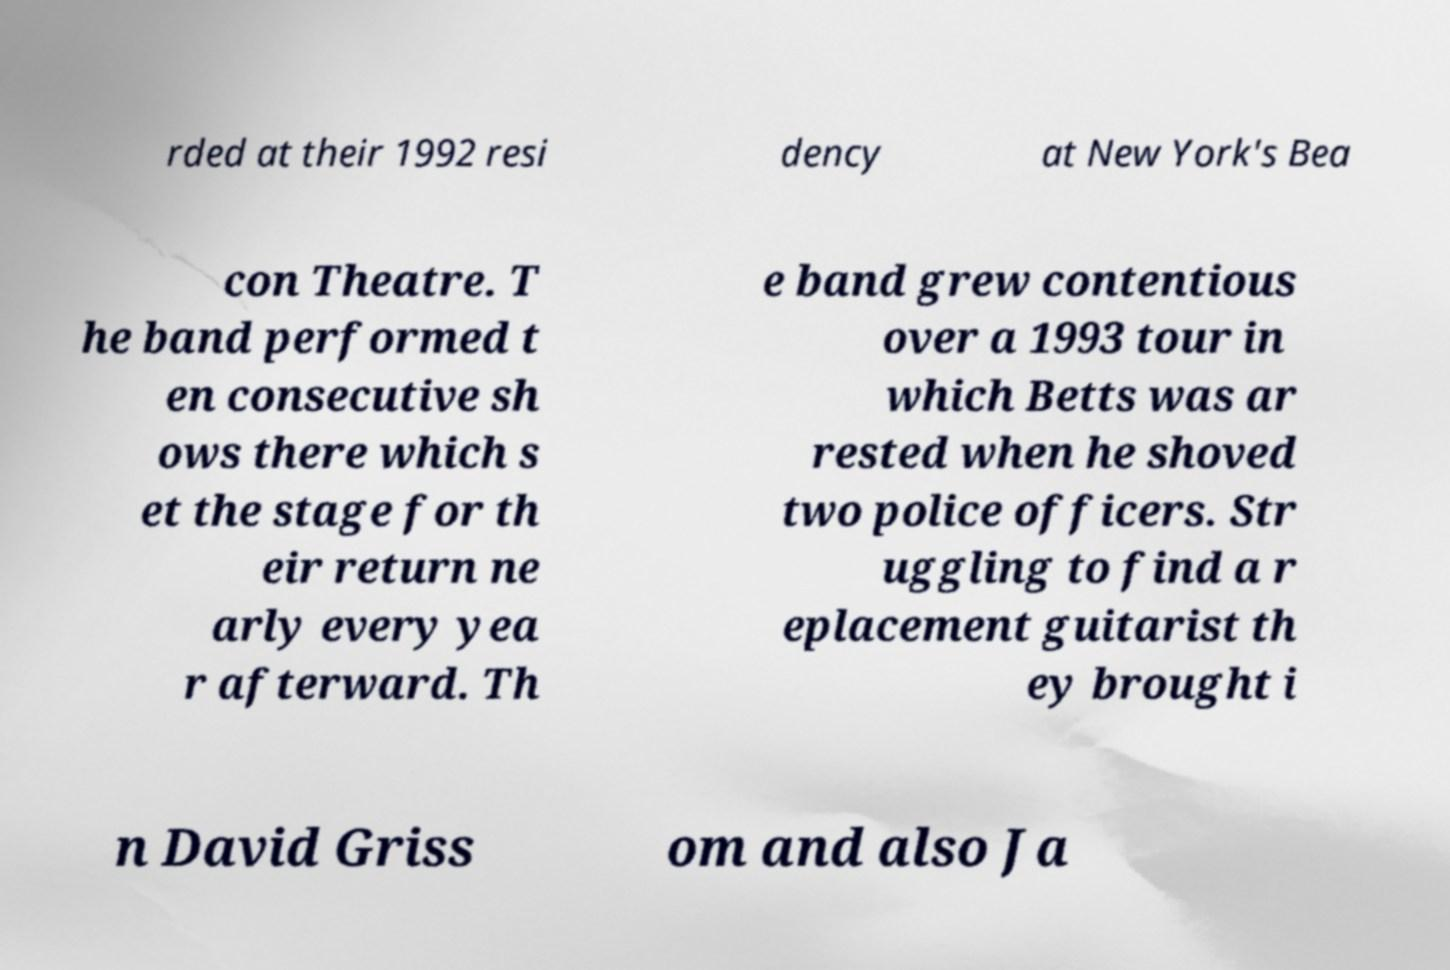What messages or text are displayed in this image? I need them in a readable, typed format. rded at their 1992 resi dency at New York's Bea con Theatre. T he band performed t en consecutive sh ows there which s et the stage for th eir return ne arly every yea r afterward. Th e band grew contentious over a 1993 tour in which Betts was ar rested when he shoved two police officers. Str uggling to find a r eplacement guitarist th ey brought i n David Griss om and also Ja 